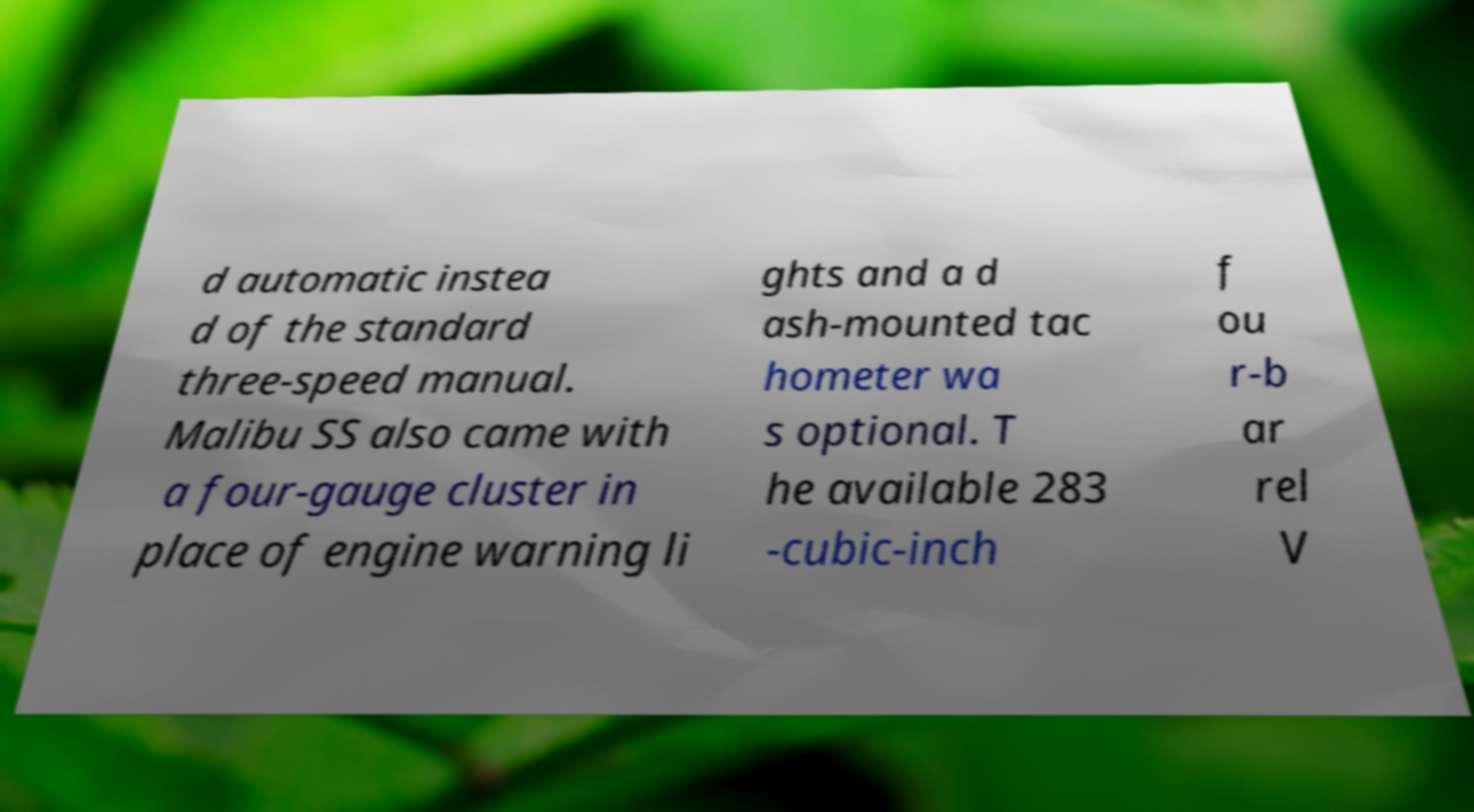I need the written content from this picture converted into text. Can you do that? d automatic instea d of the standard three-speed manual. Malibu SS also came with a four-gauge cluster in place of engine warning li ghts and a d ash-mounted tac hometer wa s optional. T he available 283 -cubic-inch f ou r-b ar rel V 